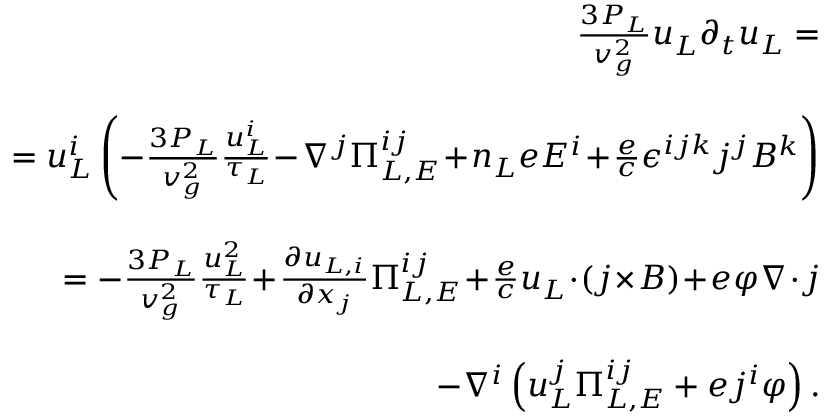<formula> <loc_0><loc_0><loc_500><loc_500>\begin{array} { r l r } & { \, \frac { 3 P _ { L } } { v _ { g } ^ { 2 } } u _ { L } \partial _ { t } u _ { L } = } \\ & \\ & { \quad = u _ { L } ^ { i } \left ( - \frac { 3 P _ { L } } { v _ { g } ^ { 2 } } \frac { u _ { L } ^ { i } } { \tau _ { L } } \, - \, \nabla ^ { j } \Pi _ { L , E } ^ { i j } \, + \, n _ { L } e E ^ { i } \, + \, \frac { e } { c } \epsilon ^ { i j k } j ^ { j } B ^ { k } \right ) } \\ & \\ & { \quad = - \frac { 3 P _ { L } } { v _ { g } ^ { 2 } } \frac { u _ { L } ^ { 2 } } { \tau _ { L } } \, + \, \frac { \partial u _ { L , i } } { \partial x _ { j } } \Pi _ { L , E } ^ { i j } \, + \, \frac { e } { c } u _ { L } \, \cdot \, ( j \, \times \, B ) \, + \, e \varphi \nabla \, \cdot \, j } \\ & \\ & { \quad - \nabla ^ { i } \left ( u _ { L } ^ { j } \Pi _ { L , E } ^ { i j } + e j ^ { i } \varphi \right ) . } \end{array}</formula> 